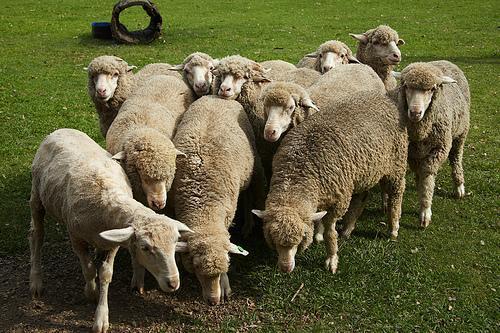How many people are in the photo?
Give a very brief answer. 0. 